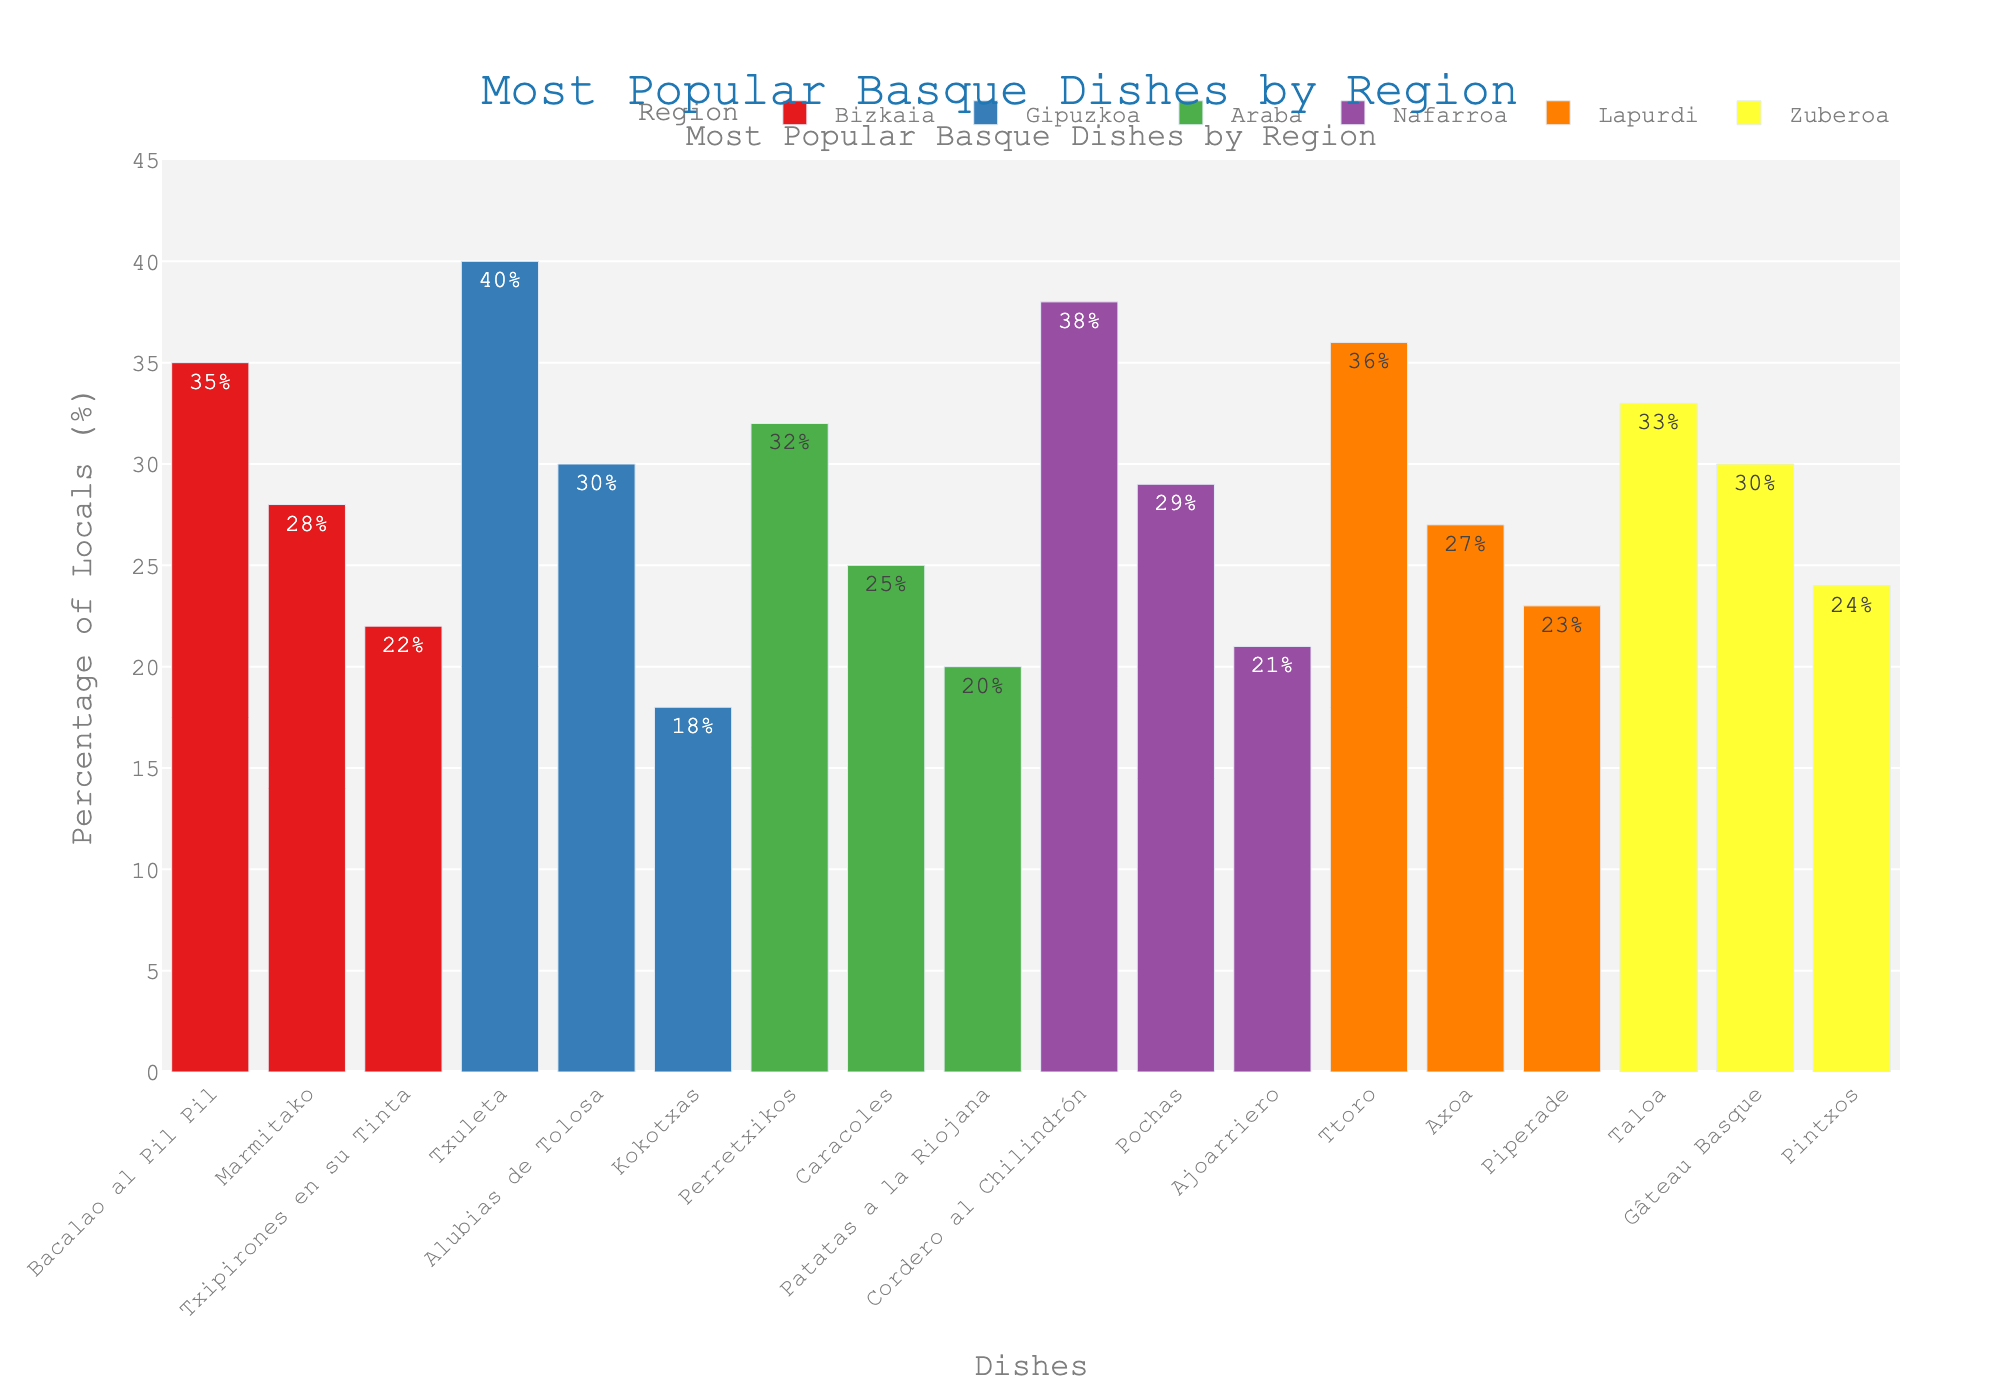What is the most popular dish in Gipuzkoa? The highest bar in the region Gipuzkoa represents the dish Txuleta with a value of 40%. This indicates that Txuleta is the most preferred dish in Gipuzkoa.
Answer: Txuleta Which region has the highest preference for Bacalao al Pil Pil? By comparing the heights of the bars labeled Bacalao al Pil Pil across different regions, only Bizkaia has a bar for this dish with a percentage value of 35%. Thus, Bizkaia has the highest preference for Bacalao al Pil Pil.
Answer: Bizkaia Which dish has the lower preference: Pochas in Nafarroa or Kokotxas in Gipuzkoa? The bar for Pochas in Nafarroa shows a percentage of 29%, while the bar for Kokotxas in Gipuzkoa shows 18%. Therefore, Kokotxas in Gipuzkoa has a lower preference.
Answer: Kokotxas in Gipuzkoa What’s the combined percentage for the top two dishes in Lapurdi? The two highest bars in Lapurdi are Ttoro with 36% and Axoa with 27%. Adding these percentages together gives a combined value of 36% + 27% = 63%.
Answer: 63% Which region has the least preference for any single dish, and what is the percentage? Identifying the lowest among all the bars, Patatas a la Riojana in Araba has a preference value of 20%, which is the minimum percentage of preference for any single dish across all regions.
Answer: Araba with 20% In which region is the preference for Taloa higher: Zuberoa or Gipuzkoa? The bar for Taloa exists only in Zuberoa with a percentage of 33%. Since there is no bar for Taloa in Gipuzkoa, it indicates the preference for Taloa is higher in Zuberoa by default.
Answer: Zuberoa How does the popularity of Txipirones en su Tinta in Bizkaia compare to Patatas a la Riojana in Araba? The bar for Txipirones en su Tinta in Bizkaia shows 22% while the bar for Patatas a la Riojana in Araba shows 20%. Comparing these values, Txipirones en su Tinta is more popular by 2%.
Answer: Txipirones en su Tinta is more popular What is the average percentage for the preferred dish across each region? The top dishes of each region have the following percentages: Bizkaia (Bacalao al Pil Pil) - 35%, Gipuzkoa (Txuleta) - 40%, Araba (Perretxikos) - 32%, Nafarroa (Cordero al Chilindrón) - 38%, Lapurdi (Ttoro) - 36%, Zuberoa (Taloa) - 33%. Summing these gives 35 + 40 + 32 + 38 + 36 + 33 = 214. Dividing by the number of regions (6), the average percentage is 214 / 6 = 35.67%.
Answer: 35.67% What is the height comparison between Gâteau Basque and Piperade in Lapurdi? The bars for Gâteau Basque in Zuberoa and Piperade in Lapurdi need to be compared. Gâteau Basque shows 30% and Piperade shows 23%. Gâteau Basque has a higher bar, indicating it is more preferred.
Answer: Gâteau Basque is higher 